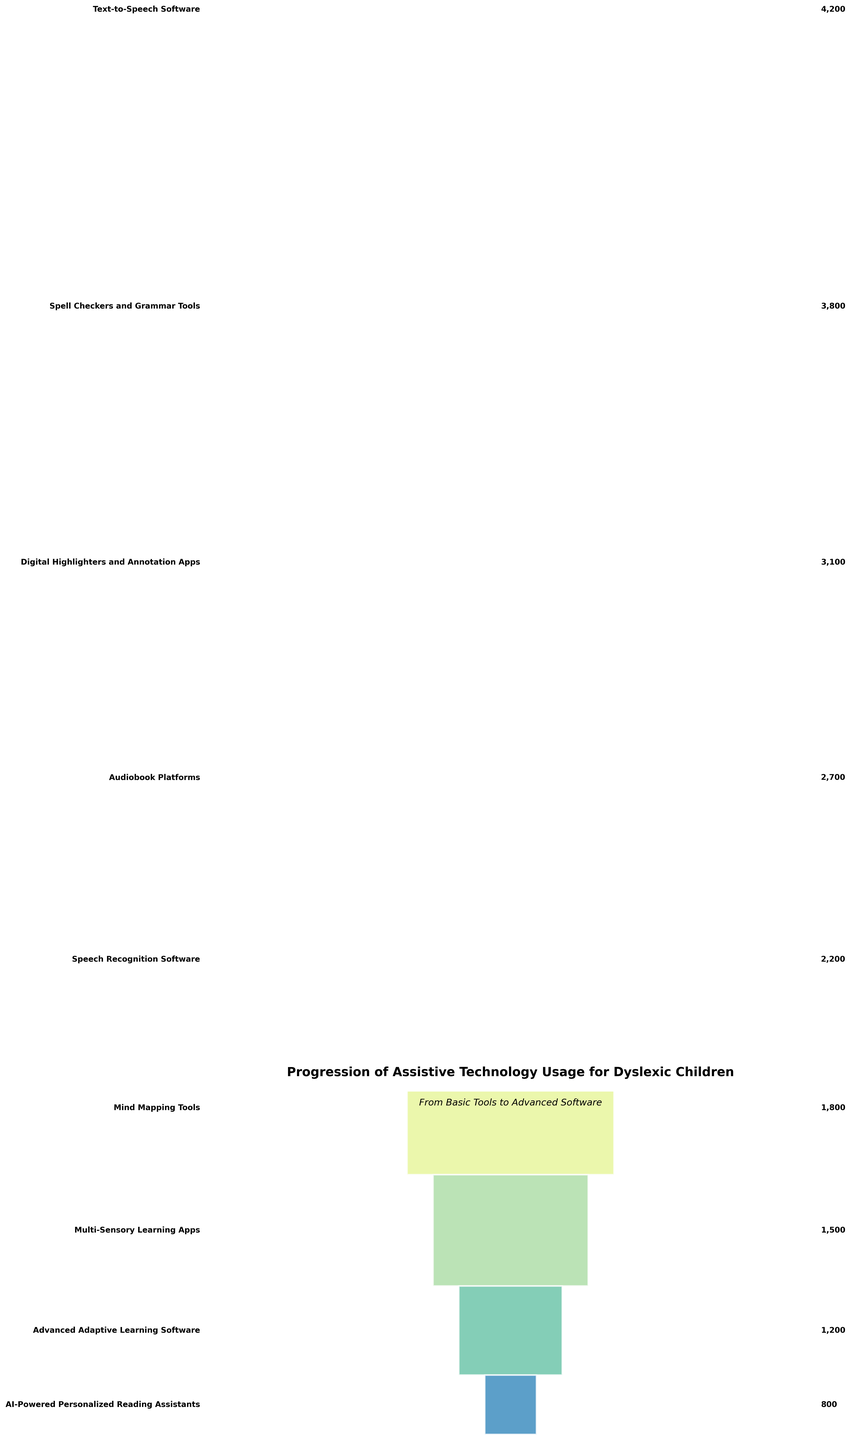What is the total number of learners using Text-to-Speech Software? The label associated with the Text-to-Speech Software bar indicates the number of users. Looking at the figure, the number is clearly shown.
Answer: 4200 How does the number of users for Digital Highlighters and Annotation Apps compare to Spell Checkers and Grammar Tools? The bar for Digital Highlighters and Annotation Apps shows 3100 users, while the bar for Spell Checkers and Grammar Tools shows 3800 users. Comparing these two values, Spell Checkers and Grammar Tools have more users.
Answer: Spell Checkers and Grammar Tools have more users What is the difference between the number of users of Mind Mapping Tools and Advanced Adaptive Learning Software? The figure indicates that Mind Mapping Tools have 1800 users and Advanced Adaptive Learning Software has 1200 users. Subtracting the latter from the former gives 1800 - 1200, which is 600.
Answer: 600 Which assistive technology has the least number of users? The smallest bar in the funnel corresponds to the AI-Powered Personalized Reading Assistants.
Answer: AI-Powered Personalized Reading Assistants What is the combined number of users for the top three assistive technologies? The top three assistive technologies in terms of users are Text-to-Speech Software (4200 users), Spell Checkers and Grammar Tools (3800 users), and Digital Highlighters and Annotation Apps (3100 users). Adding these together gives 4200 + 3800 + 3100 = 11100.
Answer: 11100 How many more users are there for Audiobook Platforms compared to Multi-Sensory Learning Apps? The figure shows Audiobook Platforms have 2700 users while Multi-Sensory Learning Apps have 1500 users. The difference is 2700 - 1500 = 1200.
Answer: 1200 Which stage precedes the use of AI-Powered Personalized Reading Assistants in terms of user numbers? The stage immediately above AI-Powered Personalized Reading Assistants (800 users) is Advanced Adaptive Learning Software, which has 1200 users.
Answer: Advanced Adaptive Learning Software What is the median number of users in the assistive technology stages? Listing the number of users in order: 4200, 3800, 3100, 2700, 2200, 1800, 1500, 1200, 800, the median is the middle value of the sorted dataset. Thus, the median is 2200.
Answer: 2200 Which assistive technology stage has twice the users of Speech Recognition Software? Speech Recognition Software has 2200 users. Twice this number is 2200 * 2 = 4400. No stage exactly matches 4400 users, but the closest user count is for Text-to-Speech Software with 4200 users, which is not exactly twice but closest.
Answer: No stage exactly matches, Text-to-Speech Software is closest 